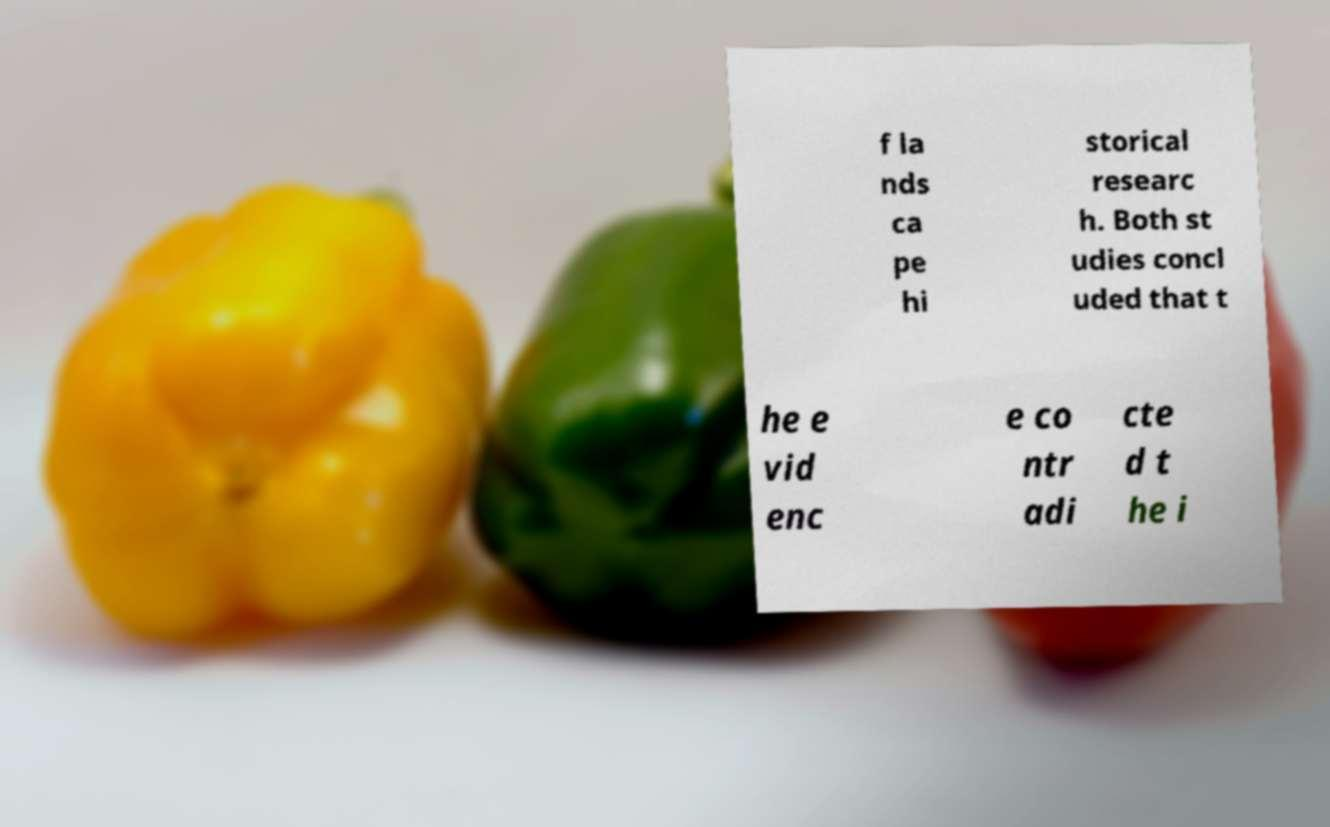There's text embedded in this image that I need extracted. Can you transcribe it verbatim? f la nds ca pe hi storical researc h. Both st udies concl uded that t he e vid enc e co ntr adi cte d t he i 